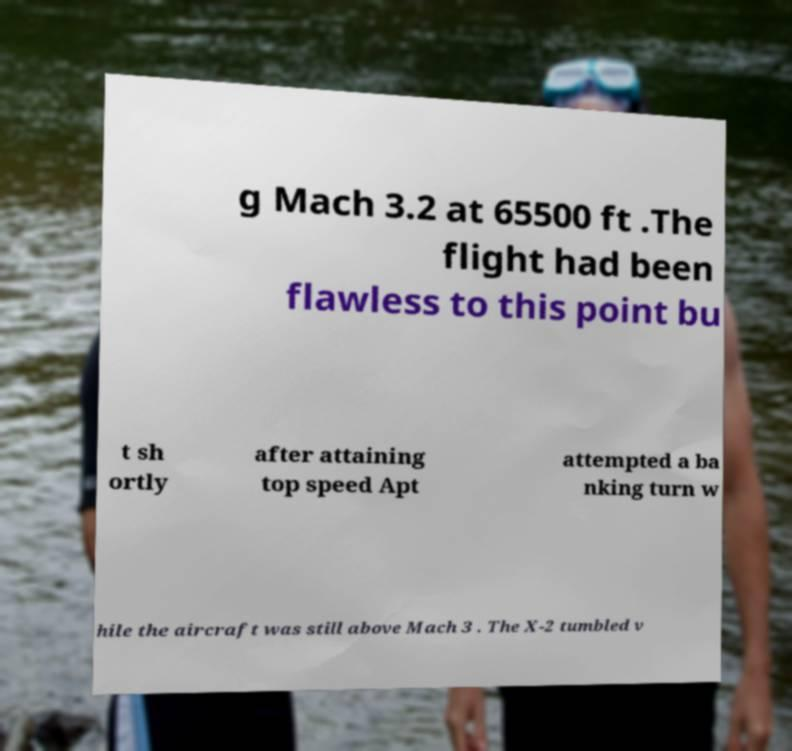Could you extract and type out the text from this image? g Mach 3.2 at 65500 ft .The flight had been flawless to this point bu t sh ortly after attaining top speed Apt attempted a ba nking turn w hile the aircraft was still above Mach 3 . The X-2 tumbled v 